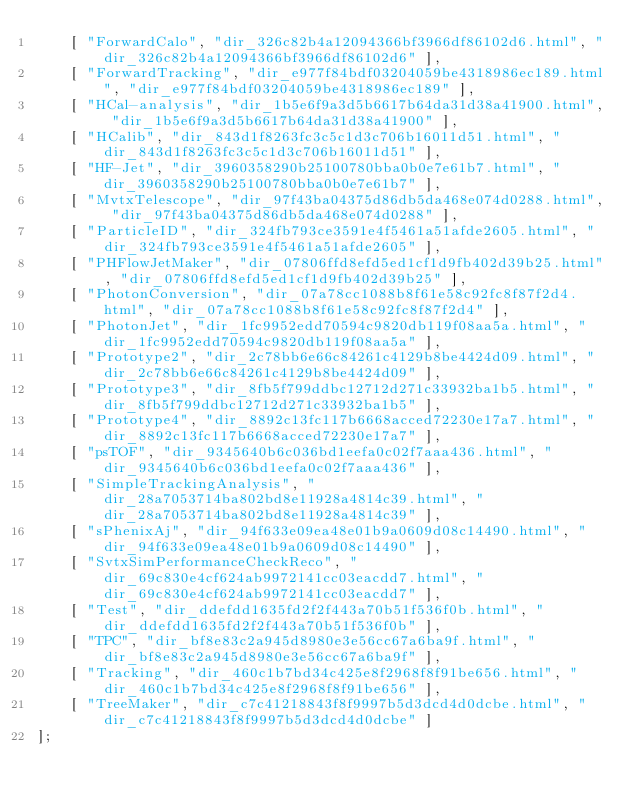Convert code to text. <code><loc_0><loc_0><loc_500><loc_500><_JavaScript_>    [ "ForwardCalo", "dir_326c82b4a12094366bf3966df86102d6.html", "dir_326c82b4a12094366bf3966df86102d6" ],
    [ "ForwardTracking", "dir_e977f84bdf03204059be4318986ec189.html", "dir_e977f84bdf03204059be4318986ec189" ],
    [ "HCal-analysis", "dir_1b5e6f9a3d5b6617b64da31d38a41900.html", "dir_1b5e6f9a3d5b6617b64da31d38a41900" ],
    [ "HCalib", "dir_843d1f8263fc3c5c1d3c706b16011d51.html", "dir_843d1f8263fc3c5c1d3c706b16011d51" ],
    [ "HF-Jet", "dir_3960358290b25100780bba0b0e7e61b7.html", "dir_3960358290b25100780bba0b0e7e61b7" ],
    [ "MvtxTelescope", "dir_97f43ba04375d86db5da468e074d0288.html", "dir_97f43ba04375d86db5da468e074d0288" ],
    [ "ParticleID", "dir_324fb793ce3591e4f5461a51afde2605.html", "dir_324fb793ce3591e4f5461a51afde2605" ],
    [ "PHFlowJetMaker", "dir_07806ffd8efd5ed1cf1d9fb402d39b25.html", "dir_07806ffd8efd5ed1cf1d9fb402d39b25" ],
    [ "PhotonConversion", "dir_07a78cc1088b8f61e58c92fc8f87f2d4.html", "dir_07a78cc1088b8f61e58c92fc8f87f2d4" ],
    [ "PhotonJet", "dir_1fc9952edd70594c9820db119f08aa5a.html", "dir_1fc9952edd70594c9820db119f08aa5a" ],
    [ "Prototype2", "dir_2c78bb6e66c84261c4129b8be4424d09.html", "dir_2c78bb6e66c84261c4129b8be4424d09" ],
    [ "Prototype3", "dir_8fb5f799ddbc12712d271c33932ba1b5.html", "dir_8fb5f799ddbc12712d271c33932ba1b5" ],
    [ "Prototype4", "dir_8892c13fc117b6668acced72230e17a7.html", "dir_8892c13fc117b6668acced72230e17a7" ],
    [ "psTOF", "dir_9345640b6c036bd1eefa0c02f7aaa436.html", "dir_9345640b6c036bd1eefa0c02f7aaa436" ],
    [ "SimpleTrackingAnalysis", "dir_28a7053714ba802bd8e11928a4814c39.html", "dir_28a7053714ba802bd8e11928a4814c39" ],
    [ "sPhenixAj", "dir_94f633e09ea48e01b9a0609d08c14490.html", "dir_94f633e09ea48e01b9a0609d08c14490" ],
    [ "SvtxSimPerformanceCheckReco", "dir_69c830e4cf624ab9972141cc03eacdd7.html", "dir_69c830e4cf624ab9972141cc03eacdd7" ],
    [ "Test", "dir_ddefdd1635fd2f2f443a70b51f536f0b.html", "dir_ddefdd1635fd2f2f443a70b51f536f0b" ],
    [ "TPC", "dir_bf8e83c2a945d8980e3e56cc67a6ba9f.html", "dir_bf8e83c2a945d8980e3e56cc67a6ba9f" ],
    [ "Tracking", "dir_460c1b7bd34c425e8f2968f8f91be656.html", "dir_460c1b7bd34c425e8f2968f8f91be656" ],
    [ "TreeMaker", "dir_c7c41218843f8f9997b5d3dcd4d0dcbe.html", "dir_c7c41218843f8f9997b5d3dcd4d0dcbe" ]
];</code> 